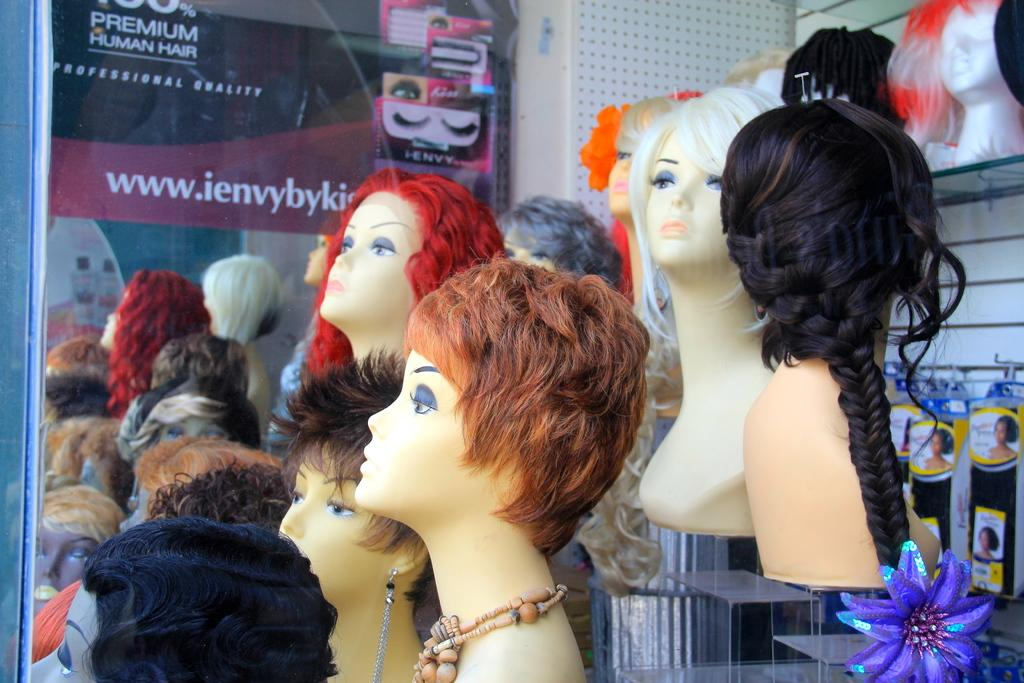Who are the people in the image? There are Mancunians in the image. What is located at the back of the image? There is a poster at the back of the image. What can be seen on the poster? There is text on the poster. What is another object in the image that reflects the Mancunians? There are reflections of Mancunians on a mirror in the image. What decision did the store make in the image? There is no store present in the image, so it is not possible to determine any decisions made by a store. 